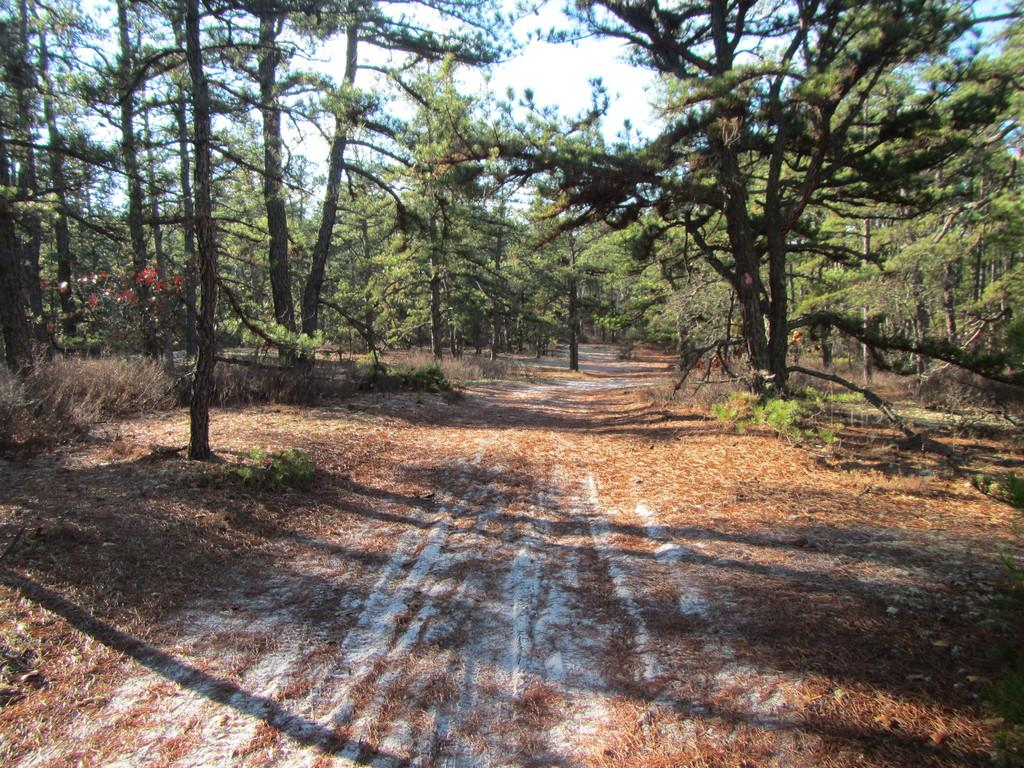What type of vegetation can be seen in the image? There are trees in the image. What is on the ground beneath the trees? Leaves are present on the ground. What is the condition of the sky in the image? The sky is cloudy in the image. Are there any poisonous snails visible in the image? There are no snails, poisonous or otherwise, visible in the image. Is there a zoo present in the image? There is no zoo present in the image; it features trees, leaves, and a cloudy sky. 